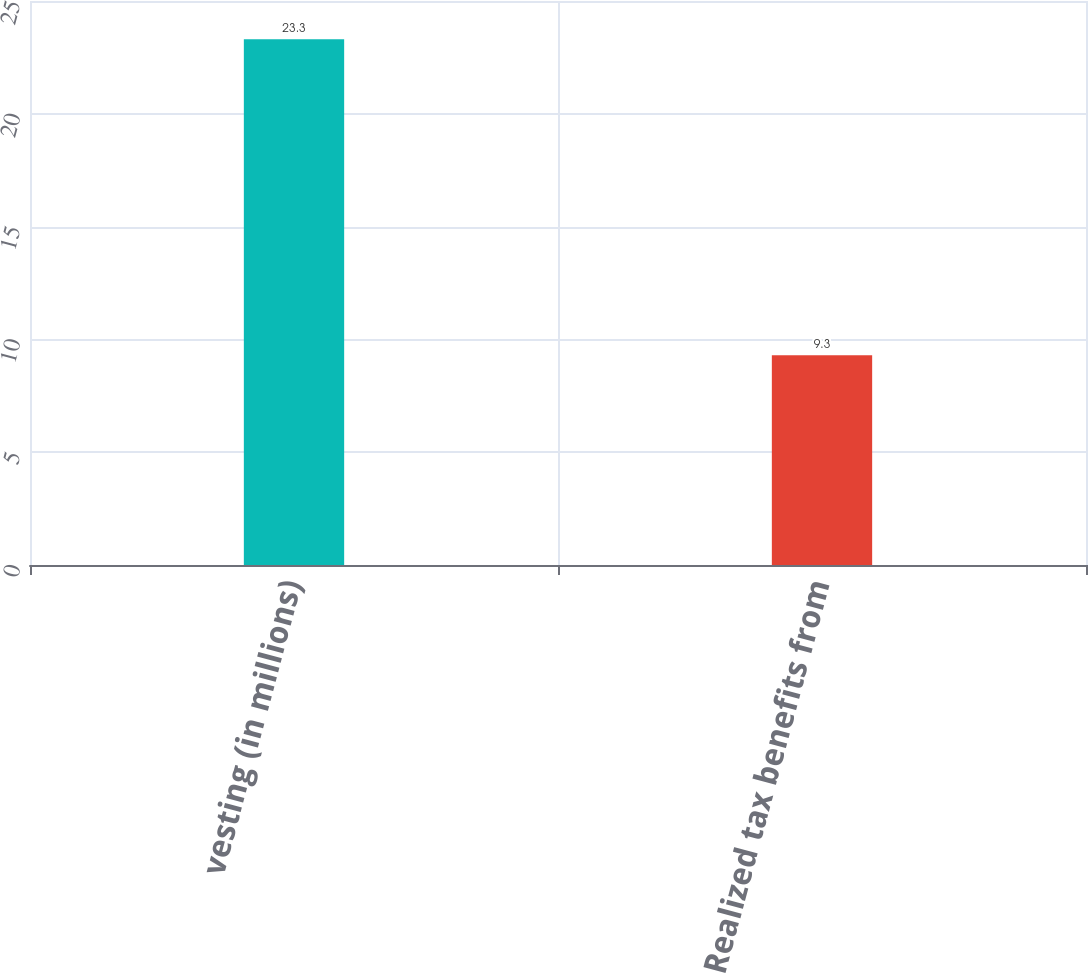Convert chart. <chart><loc_0><loc_0><loc_500><loc_500><bar_chart><fcel>vesting (in millions)<fcel>Realized tax benefits from<nl><fcel>23.3<fcel>9.3<nl></chart> 